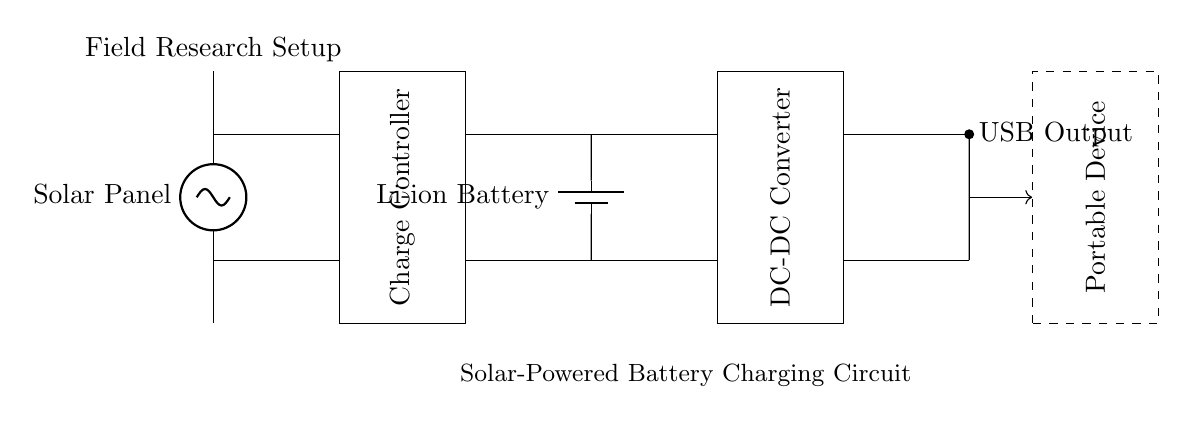What is the primary energy source in this circuit? The primary energy source is the solar panel, which converts sunlight into electrical energy.
Answer: Solar panel What component regulates the charging of the battery? The charge controller regulates the charging process of the battery, ensuring it is charged at the correct voltage and current levels.
Answer: Charge controller What type of battery is used in this circuit? The circuit uses a lithium-ion battery, indicated by the label on that component in the diagram.
Answer: Li-ion battery How many main components are involved in this circuit? There are five main components in this circuit: solar panel, charge controller, battery, DC-DC converter, and USB output.
Answer: Five What is the function of the DC-DC converter in this circuit? The DC-DC converter adjusts the voltage levels to ensure that the output is compatible with the device being charged via the USB output.
Answer: Voltage adjustment Which component produces the output for charging portable devices? The USB output provides the interface for charging portable devices, connecting the circuit to those devices.
Answer: USB output 